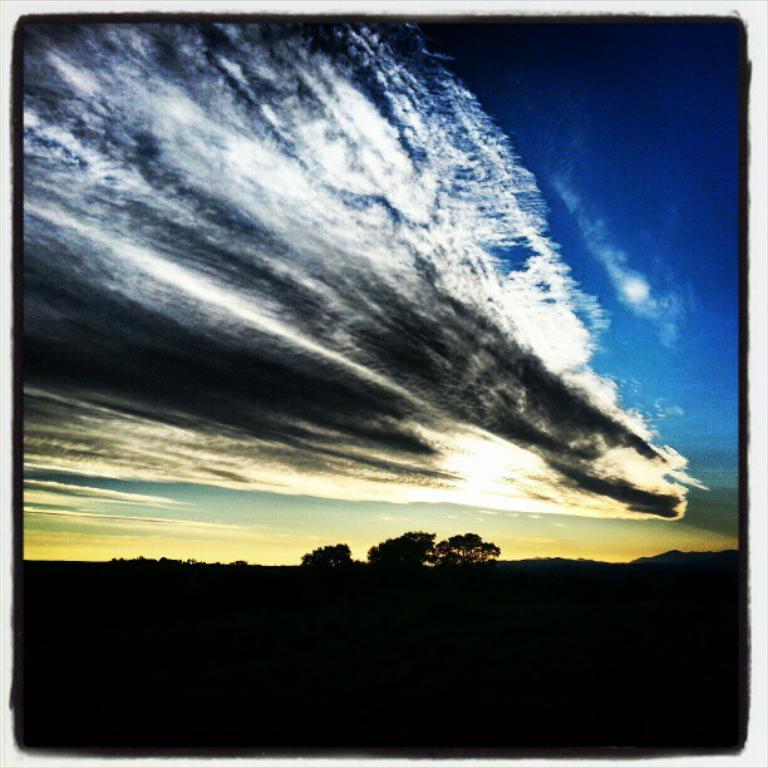What is the main feature in the center of the image? The center of the image contains the sky. What can be seen in the sky? Clouds are visible in the sky. What type of natural vegetation is present in the image? Trees are present in the image. What color is the border around the image? There is a black color border around the image. Can you tell me where the moon is located in the image? The moon is not present in the image; only the sky and clouds are visible. Is there any quicksand visible in the image? There is no quicksand present in the image; it features the sky, clouds, and trees. 